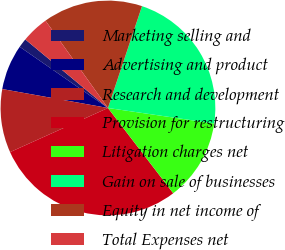<chart> <loc_0><loc_0><loc_500><loc_500><pie_chart><fcel>Marketing selling and<fcel>Advertising and product<fcel>Research and development<fcel>Provision for restructuring<fcel>Litigation charges net<fcel>Gain on sale of businesses<fcel>Equity in net income of<fcel>Total Expenses net<nl><fcel>1.37%<fcel>6.83%<fcel>9.56%<fcel>28.67%<fcel>12.29%<fcel>22.18%<fcel>15.02%<fcel>4.1%<nl></chart> 